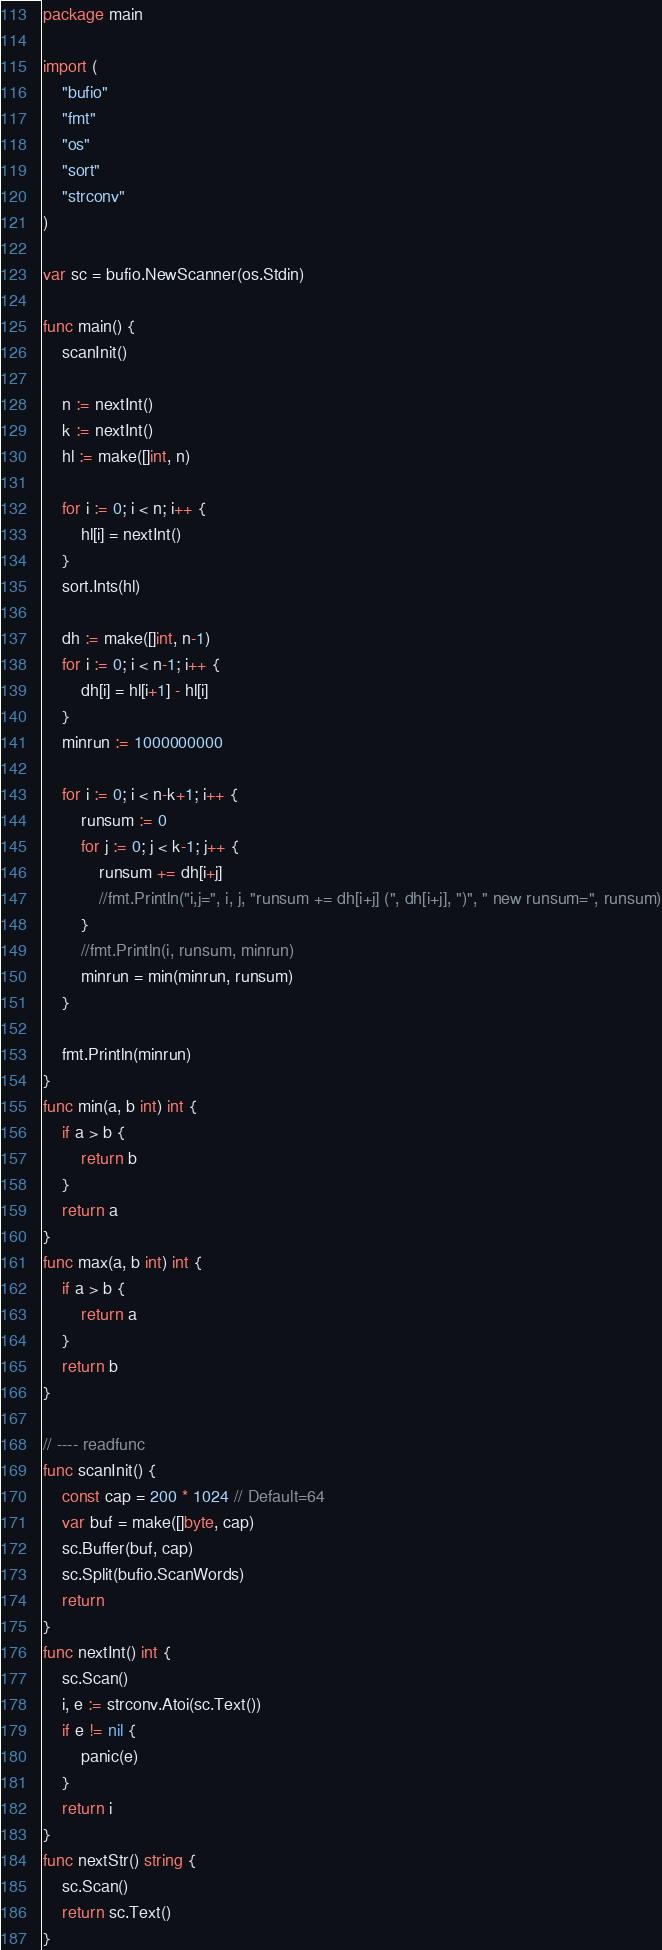Convert code to text. <code><loc_0><loc_0><loc_500><loc_500><_Go_>package main

import (
	"bufio"
	"fmt"
	"os"
	"sort"
	"strconv"
)

var sc = bufio.NewScanner(os.Stdin)

func main() {
	scanInit()

	n := nextInt()
	k := nextInt()
	hl := make([]int, n)

	for i := 0; i < n; i++ {
		hl[i] = nextInt()
	}
	sort.Ints(hl)

	dh := make([]int, n-1)
	for i := 0; i < n-1; i++ {
		dh[i] = hl[i+1] - hl[i]
	}
	minrun := 1000000000

	for i := 0; i < n-k+1; i++ {
		runsum := 0
		for j := 0; j < k-1; j++ {
			runsum += dh[i+j]
			//fmt.Println("i,j=", i, j, "runsum += dh[i+j] (", dh[i+j], ")", " new runsum=", runsum)
		}
		//fmt.Println(i, runsum, minrun)
		minrun = min(minrun, runsum)
	}

	fmt.Println(minrun)
}
func min(a, b int) int {
	if a > b {
		return b
	}
	return a
}
func max(a, b int) int {
	if a > b {
		return a
	}
	return b
}

// ---- readfunc
func scanInit() {
	const cap = 200 * 1024 // Default=64
	var buf = make([]byte, cap)
	sc.Buffer(buf, cap)
	sc.Split(bufio.ScanWords)
	return
}
func nextInt() int {
	sc.Scan()
	i, e := strconv.Atoi(sc.Text())
	if e != nil {
		panic(e)
	}
	return i
}
func nextStr() string {
	sc.Scan()
	return sc.Text()
}
</code> 